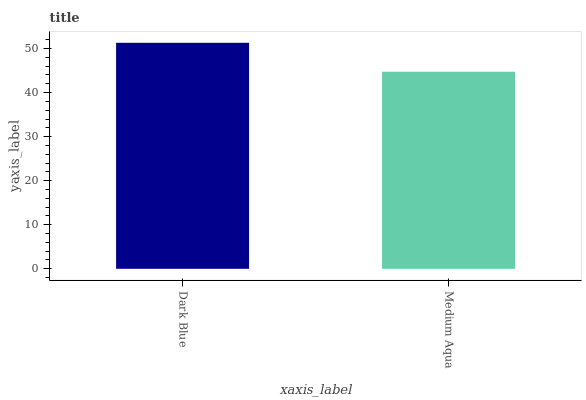Is Medium Aqua the minimum?
Answer yes or no. Yes. Is Dark Blue the maximum?
Answer yes or no. Yes. Is Medium Aqua the maximum?
Answer yes or no. No. Is Dark Blue greater than Medium Aqua?
Answer yes or no. Yes. Is Medium Aqua less than Dark Blue?
Answer yes or no. Yes. Is Medium Aqua greater than Dark Blue?
Answer yes or no. No. Is Dark Blue less than Medium Aqua?
Answer yes or no. No. Is Dark Blue the high median?
Answer yes or no. Yes. Is Medium Aqua the low median?
Answer yes or no. Yes. Is Medium Aqua the high median?
Answer yes or no. No. Is Dark Blue the low median?
Answer yes or no. No. 